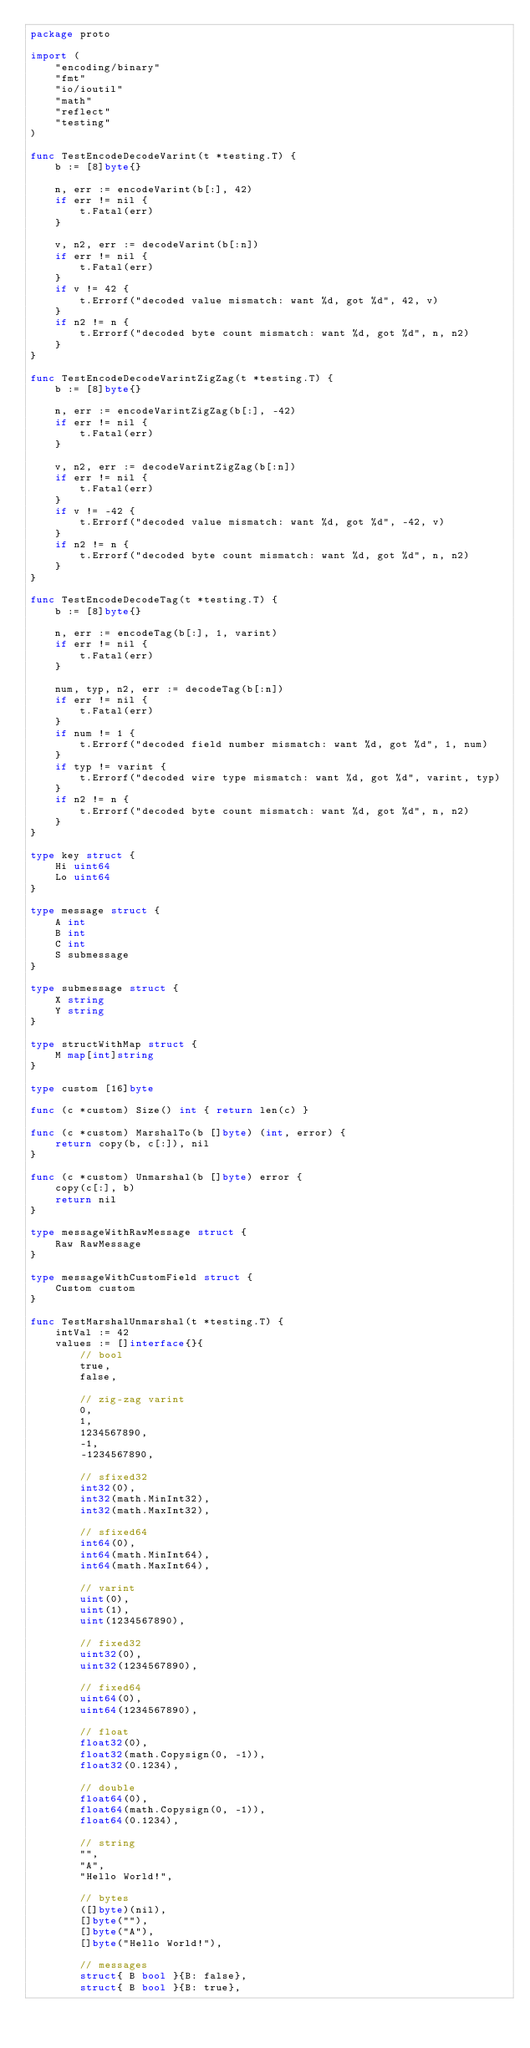Convert code to text. <code><loc_0><loc_0><loc_500><loc_500><_Go_>package proto

import (
	"encoding/binary"
	"fmt"
	"io/ioutil"
	"math"
	"reflect"
	"testing"
)

func TestEncodeDecodeVarint(t *testing.T) {
	b := [8]byte{}

	n, err := encodeVarint(b[:], 42)
	if err != nil {
		t.Fatal(err)
	}

	v, n2, err := decodeVarint(b[:n])
	if err != nil {
		t.Fatal(err)
	}
	if v != 42 {
		t.Errorf("decoded value mismatch: want %d, got %d", 42, v)
	}
	if n2 != n {
		t.Errorf("decoded byte count mismatch: want %d, got %d", n, n2)
	}
}

func TestEncodeDecodeVarintZigZag(t *testing.T) {
	b := [8]byte{}

	n, err := encodeVarintZigZag(b[:], -42)
	if err != nil {
		t.Fatal(err)
	}

	v, n2, err := decodeVarintZigZag(b[:n])
	if err != nil {
		t.Fatal(err)
	}
	if v != -42 {
		t.Errorf("decoded value mismatch: want %d, got %d", -42, v)
	}
	if n2 != n {
		t.Errorf("decoded byte count mismatch: want %d, got %d", n, n2)
	}
}

func TestEncodeDecodeTag(t *testing.T) {
	b := [8]byte{}

	n, err := encodeTag(b[:], 1, varint)
	if err != nil {
		t.Fatal(err)
	}

	num, typ, n2, err := decodeTag(b[:n])
	if err != nil {
		t.Fatal(err)
	}
	if num != 1 {
		t.Errorf("decoded field number mismatch: want %d, got %d", 1, num)
	}
	if typ != varint {
		t.Errorf("decoded wire type mismatch: want %d, got %d", varint, typ)
	}
	if n2 != n {
		t.Errorf("decoded byte count mismatch: want %d, got %d", n, n2)
	}
}

type key struct {
	Hi uint64
	Lo uint64
}

type message struct {
	A int
	B int
	C int
	S submessage
}

type submessage struct {
	X string
	Y string
}

type structWithMap struct {
	M map[int]string
}

type custom [16]byte

func (c *custom) Size() int { return len(c) }

func (c *custom) MarshalTo(b []byte) (int, error) {
	return copy(b, c[:]), nil
}

func (c *custom) Unmarshal(b []byte) error {
	copy(c[:], b)
	return nil
}

type messageWithRawMessage struct {
	Raw RawMessage
}

type messageWithCustomField struct {
	Custom custom
}

func TestMarshalUnmarshal(t *testing.T) {
	intVal := 42
	values := []interface{}{
		// bool
		true,
		false,

		// zig-zag varint
		0,
		1,
		1234567890,
		-1,
		-1234567890,

		// sfixed32
		int32(0),
		int32(math.MinInt32),
		int32(math.MaxInt32),

		// sfixed64
		int64(0),
		int64(math.MinInt64),
		int64(math.MaxInt64),

		// varint
		uint(0),
		uint(1),
		uint(1234567890),

		// fixed32
		uint32(0),
		uint32(1234567890),

		// fixed64
		uint64(0),
		uint64(1234567890),

		// float
		float32(0),
		float32(math.Copysign(0, -1)),
		float32(0.1234),

		// double
		float64(0),
		float64(math.Copysign(0, -1)),
		float64(0.1234),

		// string
		"",
		"A",
		"Hello World!",

		// bytes
		([]byte)(nil),
		[]byte(""),
		[]byte("A"),
		[]byte("Hello World!"),

		// messages
		struct{ B bool }{B: false},
		struct{ B bool }{B: true},
</code> 